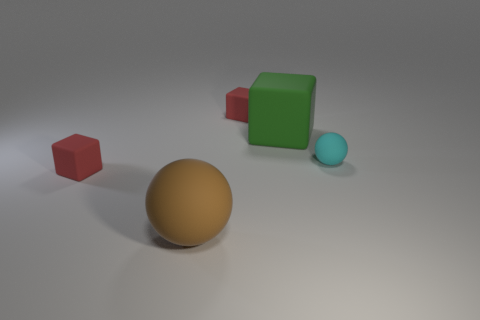Add 3 large objects. How many objects exist? 8 Subtract all large green matte cubes. How many cubes are left? 2 Subtract all green blocks. How many blocks are left? 2 Subtract 1 cubes. How many cubes are left? 2 Subtract all green balls. Subtract all yellow cylinders. How many balls are left? 2 Subtract all cyan spheres. How many green cubes are left? 1 Subtract all small rubber blocks. Subtract all big matte balls. How many objects are left? 2 Add 1 green objects. How many green objects are left? 2 Add 4 tiny balls. How many tiny balls exist? 5 Subtract 0 brown cylinders. How many objects are left? 5 